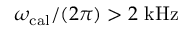<formula> <loc_0><loc_0><loc_500><loc_500>\omega _ { c a l } / ( 2 \pi ) > 2 k H z</formula> 